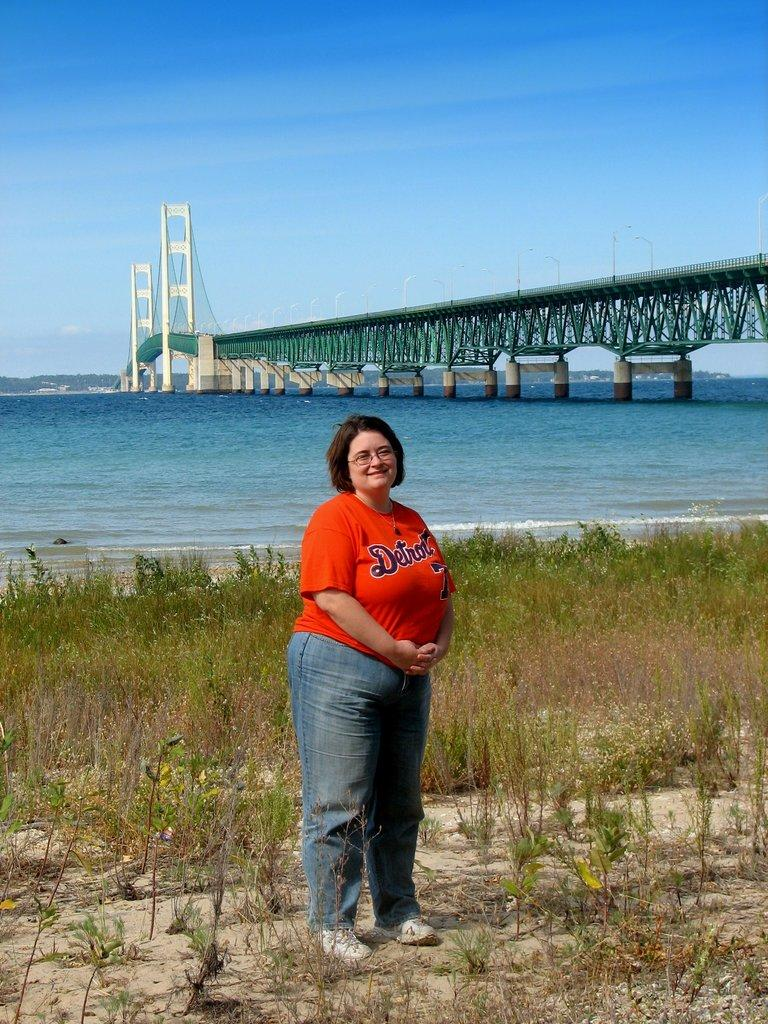Who is present in the image? There is a woman in the image. What is the woman doing in the image? The woman is standing. What is the woman wearing in the image? The woman is wearing a red T-shirt. What can be seen beside the woman in the image? There are plants beside the woman. What is visible in the background of the image? There is a bridge visible in the background of the image, and there is water under the bridge. What type of roll can be seen being hammered on the blade in the image? There is no roll, hammer, or blade present in the image. 